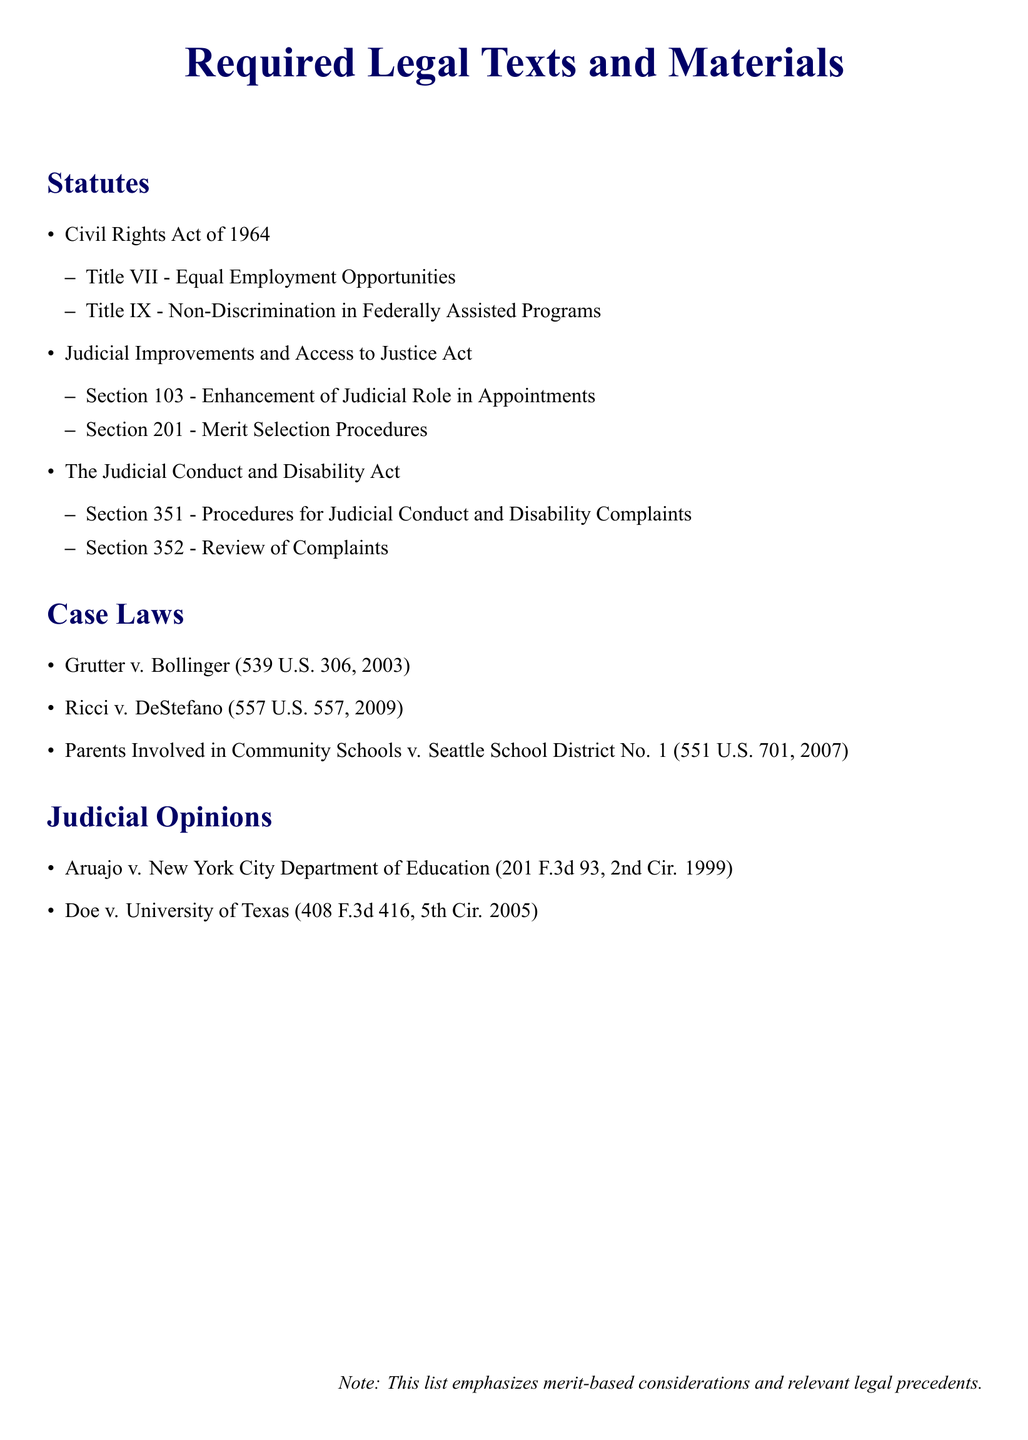What is the first statute listed? The first statute in the document is the Civil Rights Act of 1964.
Answer: Civil Rights Act of 1964 How many titles are listed under the Civil Rights Act of 1964? There are two titles mentioned under this Act: Title VII and Title IX.
Answer: 2 What is Section 201 of the Judicial Improvements and Access to Justice Act about? Section 201 pertains to Merit Selection Procedures as listed in the document.
Answer: Merit Selection Procedures Which case law was decided in 2003? The case law decided in 2003 is Grutter v. Bollinger.
Answer: Grutter v. Bollinger What does the note at the bottom of the document emphasize? The note emphasizes merit-based considerations and relevant legal precedents.
Answer: Merit-based considerations and relevant legal precedents What is the title of the second judicial opinion listed? The second judicial opinion listed is Doe v. University of Texas.
Answer: Doe v. University of Texas How many judges are referenced under the Judicial Conduct and Disability Act? The document lists two sections under the Judicial Conduct and Disability Act.
Answer: 2 Which Supreme Court case addresses community schools? Parents Involved in Community Schools v. Seattle School District No. 1 addresses this topic.
Answer: Parents Involved in Community Schools v. Seattle School District No. 1 